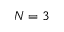Convert formula to latex. <formula><loc_0><loc_0><loc_500><loc_500>N = 3</formula> 